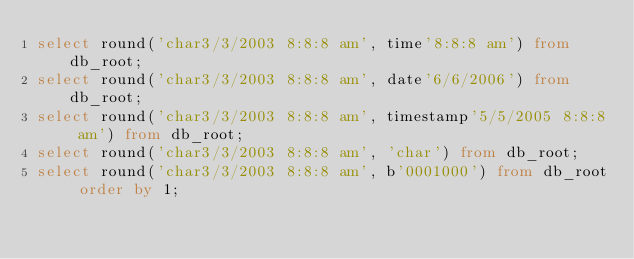<code> <loc_0><loc_0><loc_500><loc_500><_SQL_>select round('char3/3/2003 8:8:8 am', time'8:8:8 am') from db_root;
select round('char3/3/2003 8:8:8 am', date'6/6/2006') from db_root;
select round('char3/3/2003 8:8:8 am', timestamp'5/5/2005 8:8:8 am') from db_root;
select round('char3/3/2003 8:8:8 am', 'char') from db_root;
select round('char3/3/2003 8:8:8 am', b'0001000') from db_root order by 1;</code> 